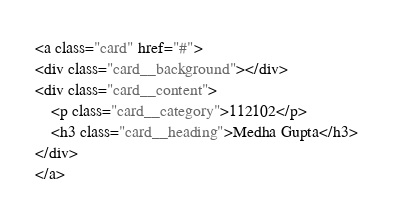Convert code to text. <code><loc_0><loc_0><loc_500><loc_500><_HTML_><a class="card" href="#">
<div class="card__background"></div>
<div class="card__content">
    <p class="card__category">112102</p>
    <h3 class="card__heading">Medha Gupta</h3>
</div>
</a>
</code> 